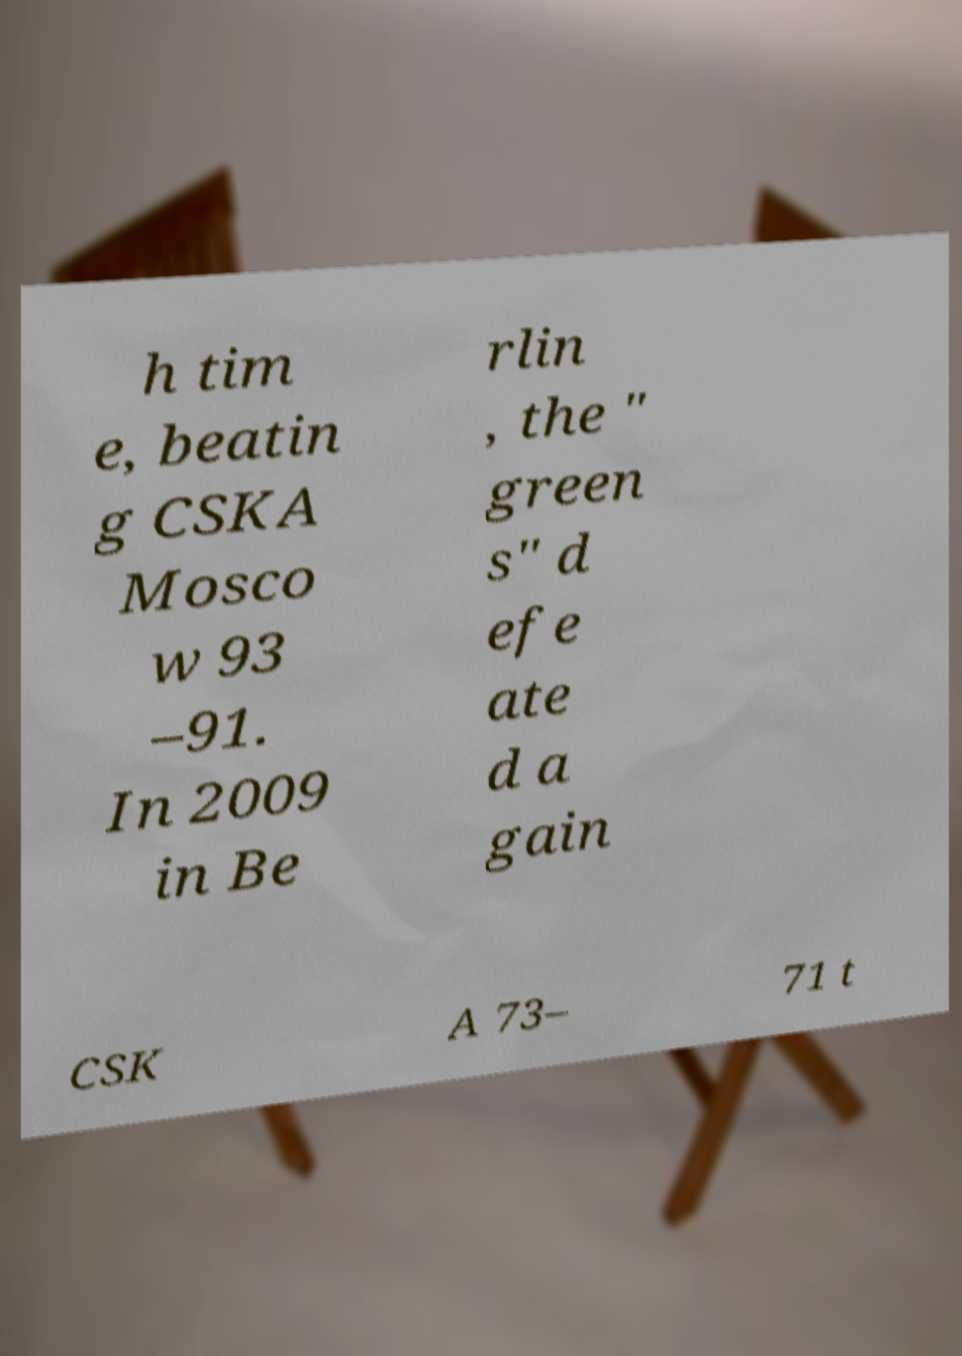Please identify and transcribe the text found in this image. h tim e, beatin g CSKA Mosco w 93 –91. In 2009 in Be rlin , the " green s" d efe ate d a gain CSK A 73– 71 t 